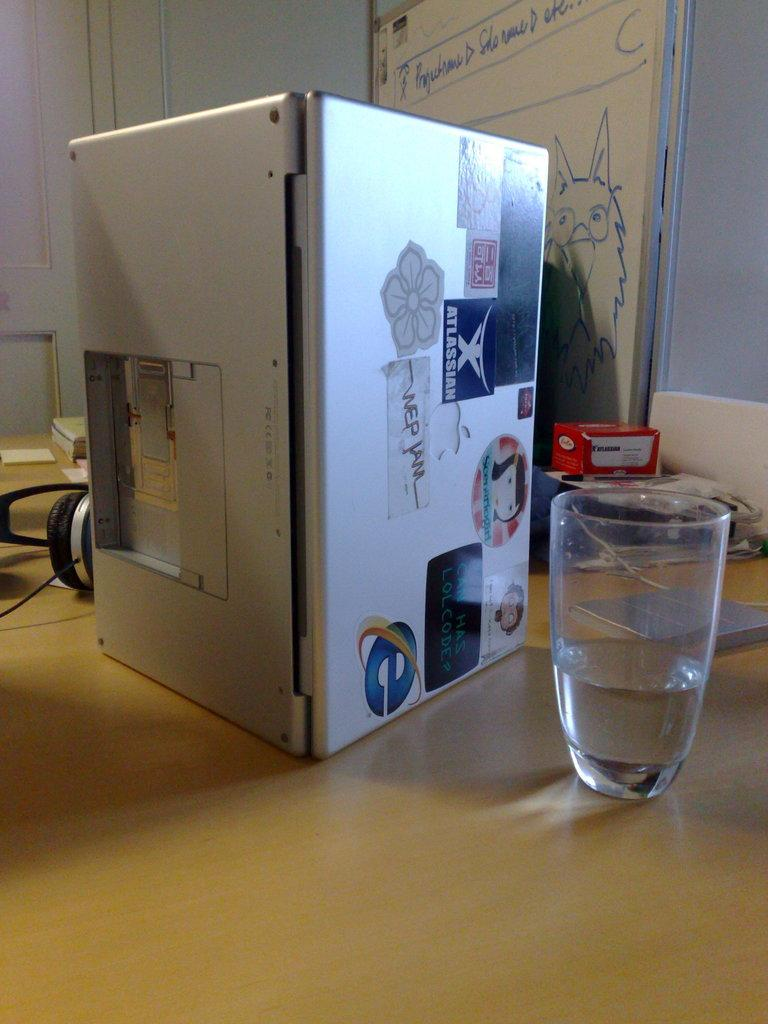<image>
Summarize the visual content of the image. A laptop computer on its side with stickers on the top, one says HAS LOLCODE 